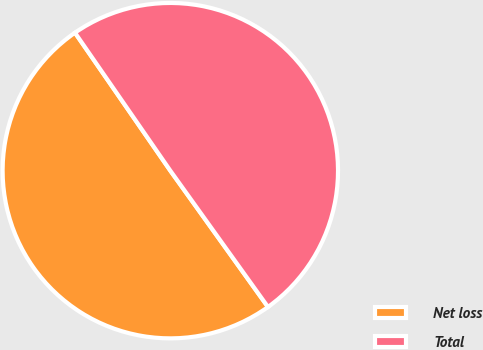Convert chart to OTSL. <chart><loc_0><loc_0><loc_500><loc_500><pie_chart><fcel>Net loss<fcel>Total<nl><fcel>50.27%<fcel>49.73%<nl></chart> 